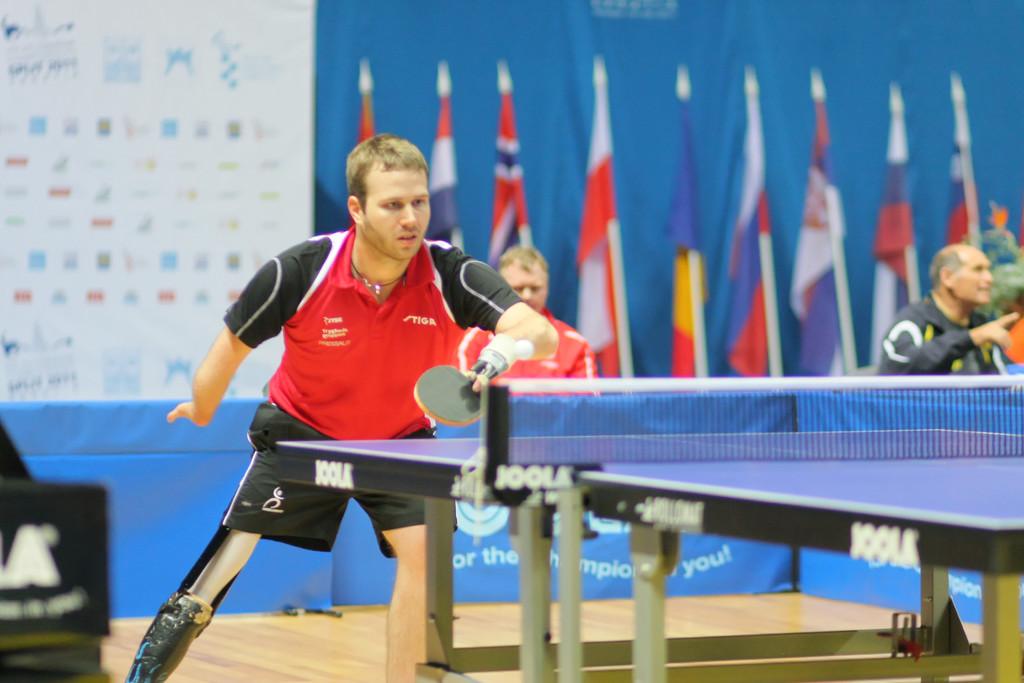What sport are they playing?
Keep it short and to the point. Answering does not require reading text in the image. What name is seen on the side of the table?
Your answer should be compact. Joola. 